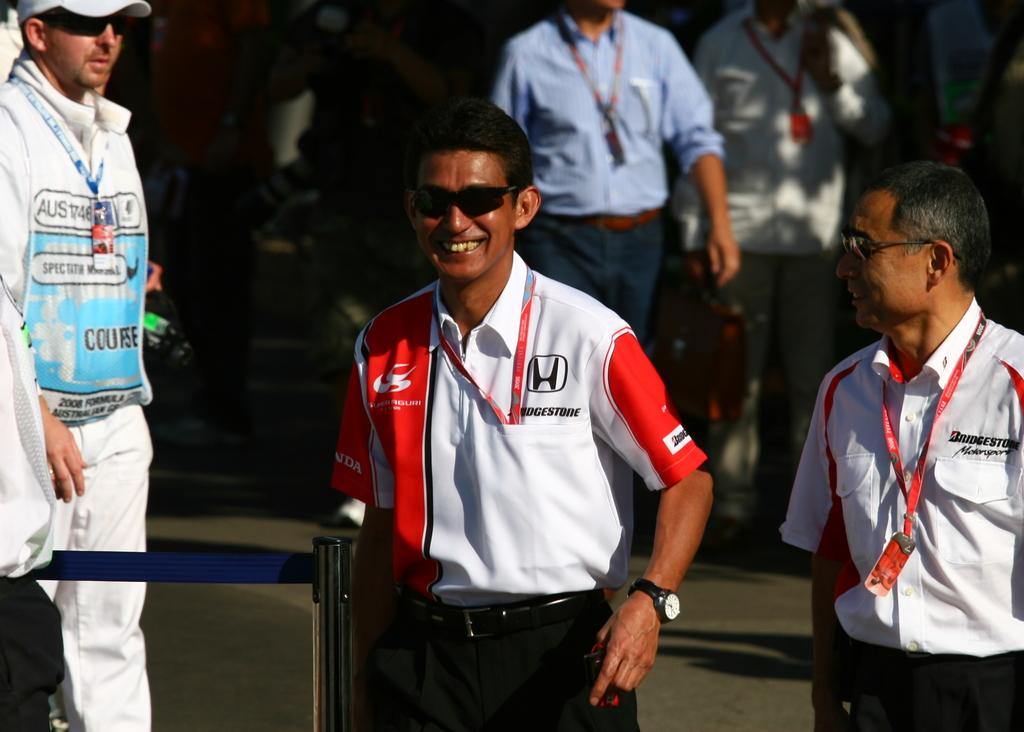Provide a one-sentence caption for the provided image. A pair of race driver smiling wearing Bridgestone sponsored shirts. 